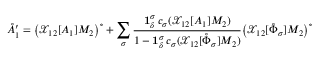Convert formula to latex. <formula><loc_0><loc_0><loc_500><loc_500>\mathring { A } _ { 1 } ^ { \prime } = \left ( \mathcal { X } _ { 1 2 } [ A _ { 1 } ] M _ { 2 } \right ) ^ { \circ } + \sum _ { \sigma } \frac { 1 _ { \delta } ^ { \sigma } \, c _ { \sigma } ( \mathcal { X } _ { 1 2 } [ A _ { 1 } ] M _ { 2 } ) } { 1 - 1 _ { \delta } ^ { \sigma } \, c _ { \sigma } ( \mathcal { X } _ { 1 2 } [ \mathring { \Phi } _ { \sigma } ] M _ { 2 } ) } \left ( \mathcal { X } _ { 1 2 } [ \mathring { \Phi } _ { \sigma } ] M _ { 2 } \right ) ^ { \circ }</formula> 